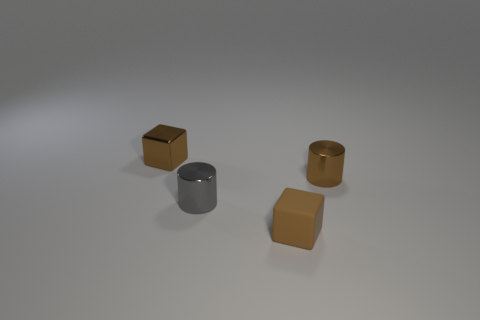What color is the small block that is left of the tiny rubber thing?
Your answer should be compact. Brown. Is the shape of the tiny matte thing the same as the brown thing on the left side of the gray metal cylinder?
Provide a short and direct response. Yes. Is there a small shiny block of the same color as the rubber block?
Offer a very short reply. Yes. There is a cube that is made of the same material as the brown cylinder; what is its size?
Your response must be concise. Small. Is the tiny shiny block the same color as the rubber block?
Provide a succinct answer. Yes. Is the shape of the brown thing in front of the small gray shiny cylinder the same as  the tiny gray metallic object?
Provide a short and direct response. No. What number of brown shiny blocks have the same size as the rubber cube?
Your answer should be compact. 1. There is a tiny matte object that is the same color as the metal cube; what shape is it?
Your answer should be compact. Cube. Is there a tiny metal thing that is behind the tiny brown object that is on the right side of the tiny rubber thing?
Your answer should be compact. Yes. How many objects are either metallic cylinders that are to the left of the matte thing or gray rubber cubes?
Keep it short and to the point. 1. 